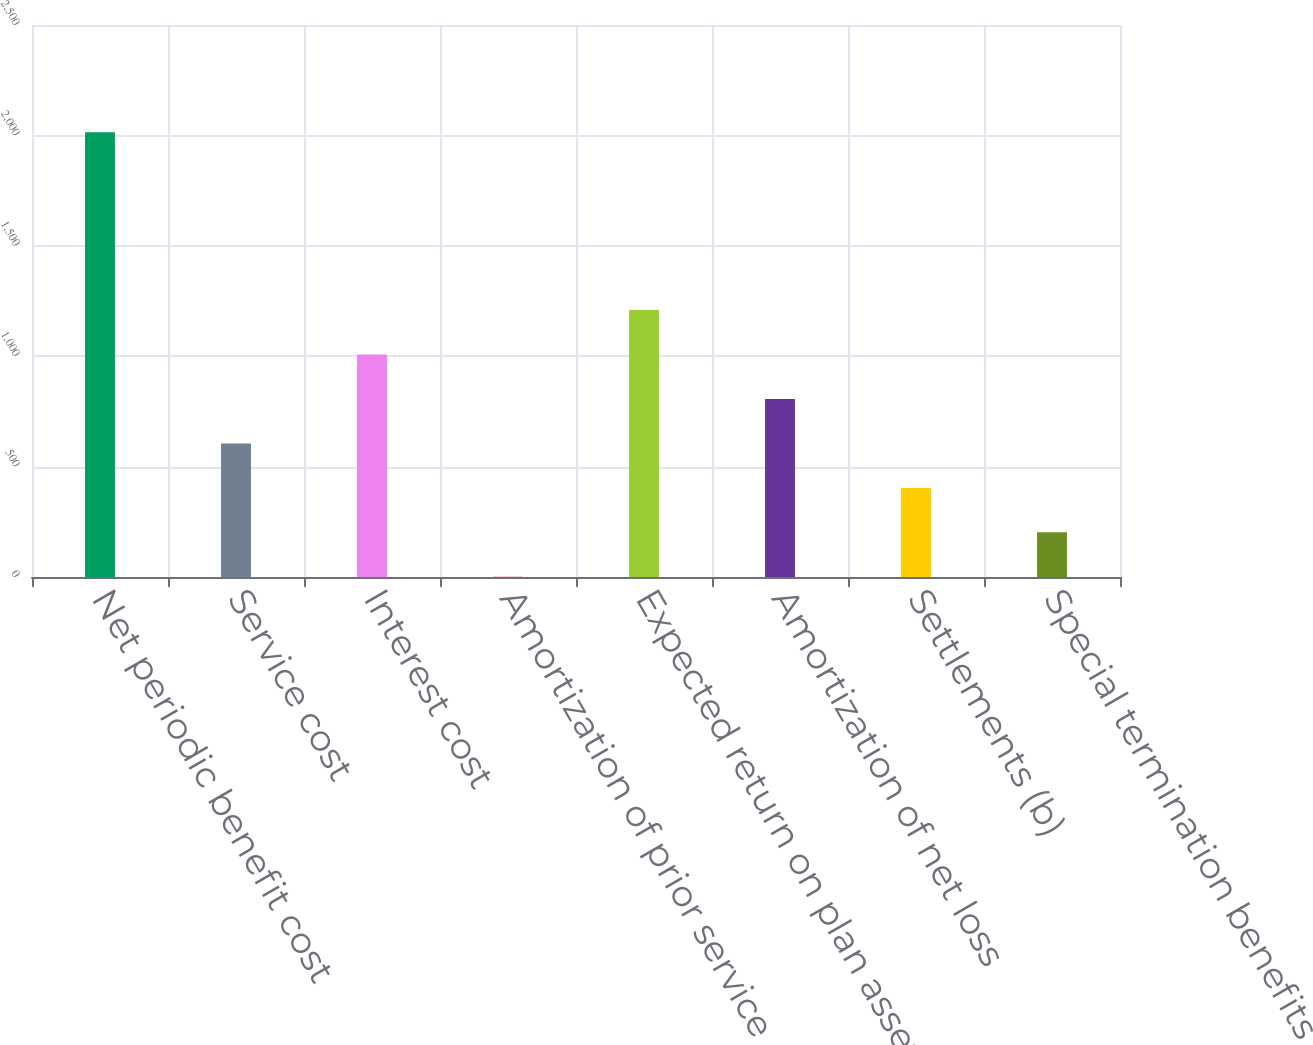<chart> <loc_0><loc_0><loc_500><loc_500><bar_chart><fcel>Net periodic benefit cost<fcel>Service cost<fcel>Interest cost<fcel>Amortization of prior service<fcel>Expected return on plan assets<fcel>Amortization of net loss<fcel>Settlements (b)<fcel>Special termination benefits<nl><fcel>2014<fcel>604.9<fcel>1007.5<fcel>1<fcel>1208.8<fcel>806.2<fcel>403.6<fcel>202.3<nl></chart> 